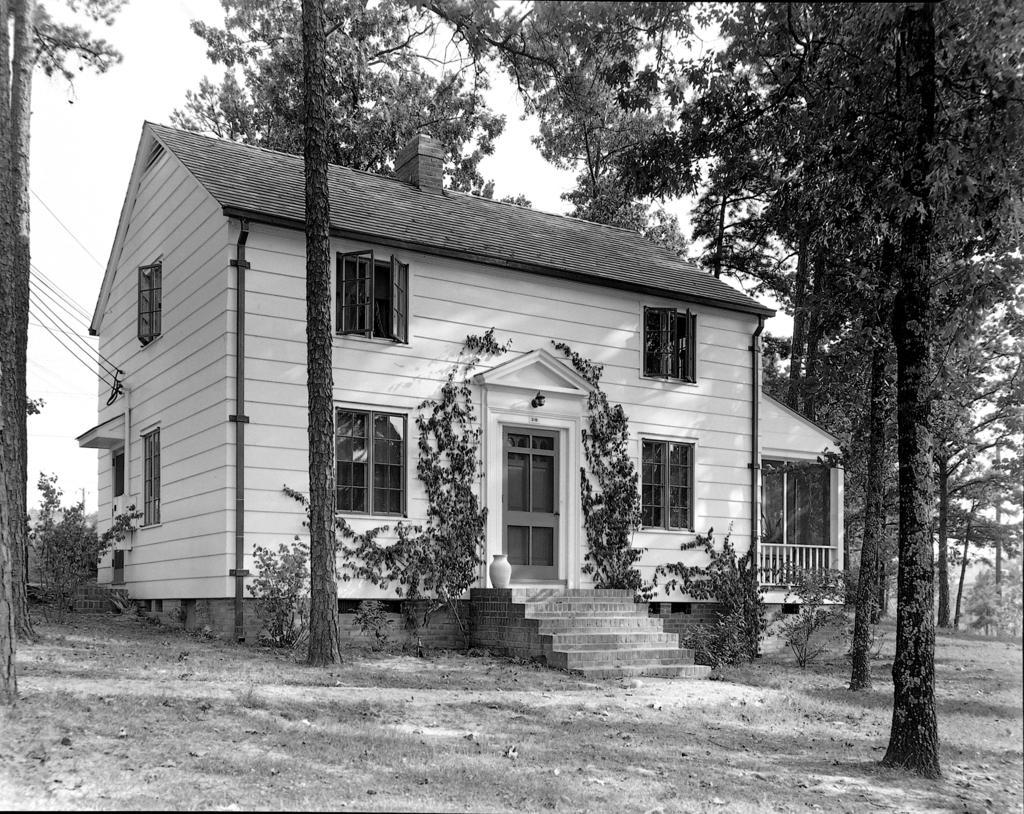Could you give a brief overview of what you see in this image? In this picture I can see there is a building and it has door, windows and stairs and there are trees and the sky is clear. 